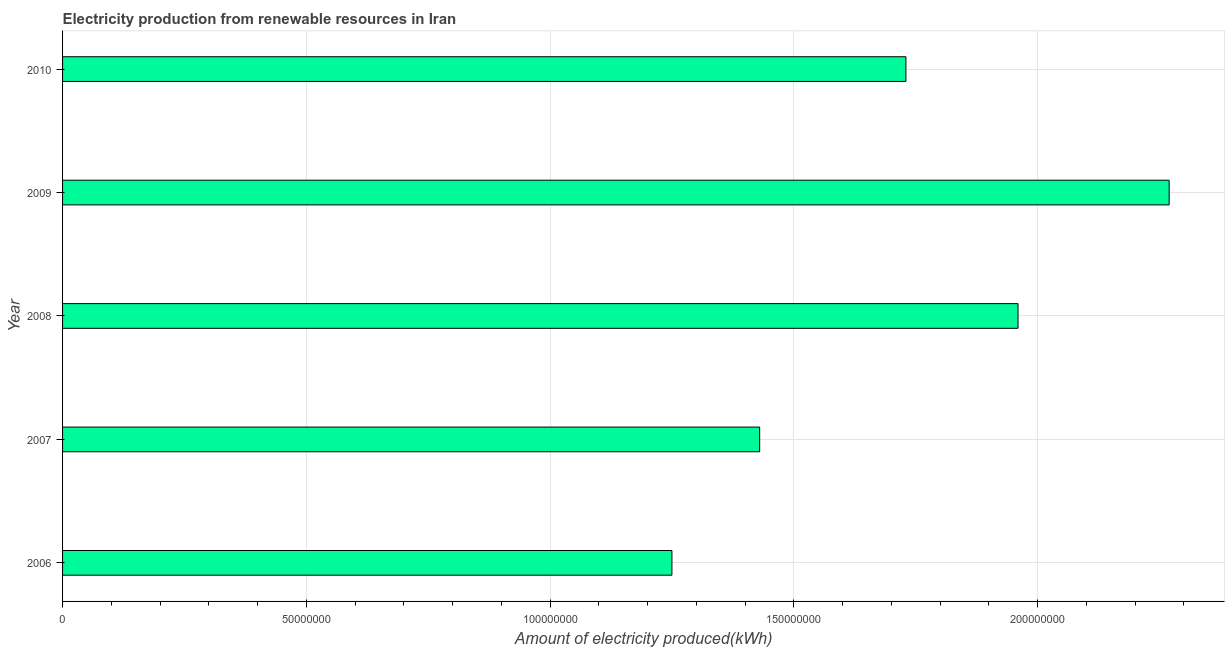Does the graph contain any zero values?
Give a very brief answer. No. What is the title of the graph?
Make the answer very short. Electricity production from renewable resources in Iran. What is the label or title of the X-axis?
Provide a succinct answer. Amount of electricity produced(kWh). What is the label or title of the Y-axis?
Ensure brevity in your answer.  Year. What is the amount of electricity produced in 2007?
Offer a terse response. 1.43e+08. Across all years, what is the maximum amount of electricity produced?
Your response must be concise. 2.27e+08. Across all years, what is the minimum amount of electricity produced?
Offer a very short reply. 1.25e+08. In which year was the amount of electricity produced minimum?
Provide a succinct answer. 2006. What is the sum of the amount of electricity produced?
Provide a succinct answer. 8.64e+08. What is the difference between the amount of electricity produced in 2008 and 2010?
Make the answer very short. 2.30e+07. What is the average amount of electricity produced per year?
Offer a terse response. 1.73e+08. What is the median amount of electricity produced?
Offer a terse response. 1.73e+08. In how many years, is the amount of electricity produced greater than 200000000 kWh?
Keep it short and to the point. 1. What is the ratio of the amount of electricity produced in 2006 to that in 2010?
Your answer should be very brief. 0.72. What is the difference between the highest and the second highest amount of electricity produced?
Provide a succinct answer. 3.10e+07. Is the sum of the amount of electricity produced in 2008 and 2009 greater than the maximum amount of electricity produced across all years?
Your response must be concise. Yes. What is the difference between the highest and the lowest amount of electricity produced?
Keep it short and to the point. 1.02e+08. In how many years, is the amount of electricity produced greater than the average amount of electricity produced taken over all years?
Your answer should be compact. 3. How many years are there in the graph?
Give a very brief answer. 5. What is the difference between two consecutive major ticks on the X-axis?
Your answer should be very brief. 5.00e+07. Are the values on the major ticks of X-axis written in scientific E-notation?
Your answer should be compact. No. What is the Amount of electricity produced(kWh) in 2006?
Provide a succinct answer. 1.25e+08. What is the Amount of electricity produced(kWh) of 2007?
Offer a very short reply. 1.43e+08. What is the Amount of electricity produced(kWh) of 2008?
Your response must be concise. 1.96e+08. What is the Amount of electricity produced(kWh) of 2009?
Provide a short and direct response. 2.27e+08. What is the Amount of electricity produced(kWh) in 2010?
Make the answer very short. 1.73e+08. What is the difference between the Amount of electricity produced(kWh) in 2006 and 2007?
Ensure brevity in your answer.  -1.80e+07. What is the difference between the Amount of electricity produced(kWh) in 2006 and 2008?
Your answer should be very brief. -7.10e+07. What is the difference between the Amount of electricity produced(kWh) in 2006 and 2009?
Offer a very short reply. -1.02e+08. What is the difference between the Amount of electricity produced(kWh) in 2006 and 2010?
Keep it short and to the point. -4.80e+07. What is the difference between the Amount of electricity produced(kWh) in 2007 and 2008?
Ensure brevity in your answer.  -5.30e+07. What is the difference between the Amount of electricity produced(kWh) in 2007 and 2009?
Provide a succinct answer. -8.40e+07. What is the difference between the Amount of electricity produced(kWh) in 2007 and 2010?
Provide a succinct answer. -3.00e+07. What is the difference between the Amount of electricity produced(kWh) in 2008 and 2009?
Make the answer very short. -3.10e+07. What is the difference between the Amount of electricity produced(kWh) in 2008 and 2010?
Your response must be concise. 2.30e+07. What is the difference between the Amount of electricity produced(kWh) in 2009 and 2010?
Your answer should be compact. 5.40e+07. What is the ratio of the Amount of electricity produced(kWh) in 2006 to that in 2007?
Offer a very short reply. 0.87. What is the ratio of the Amount of electricity produced(kWh) in 2006 to that in 2008?
Ensure brevity in your answer.  0.64. What is the ratio of the Amount of electricity produced(kWh) in 2006 to that in 2009?
Provide a succinct answer. 0.55. What is the ratio of the Amount of electricity produced(kWh) in 2006 to that in 2010?
Provide a short and direct response. 0.72. What is the ratio of the Amount of electricity produced(kWh) in 2007 to that in 2008?
Offer a terse response. 0.73. What is the ratio of the Amount of electricity produced(kWh) in 2007 to that in 2009?
Provide a short and direct response. 0.63. What is the ratio of the Amount of electricity produced(kWh) in 2007 to that in 2010?
Your answer should be very brief. 0.83. What is the ratio of the Amount of electricity produced(kWh) in 2008 to that in 2009?
Your response must be concise. 0.86. What is the ratio of the Amount of electricity produced(kWh) in 2008 to that in 2010?
Give a very brief answer. 1.13. What is the ratio of the Amount of electricity produced(kWh) in 2009 to that in 2010?
Give a very brief answer. 1.31. 